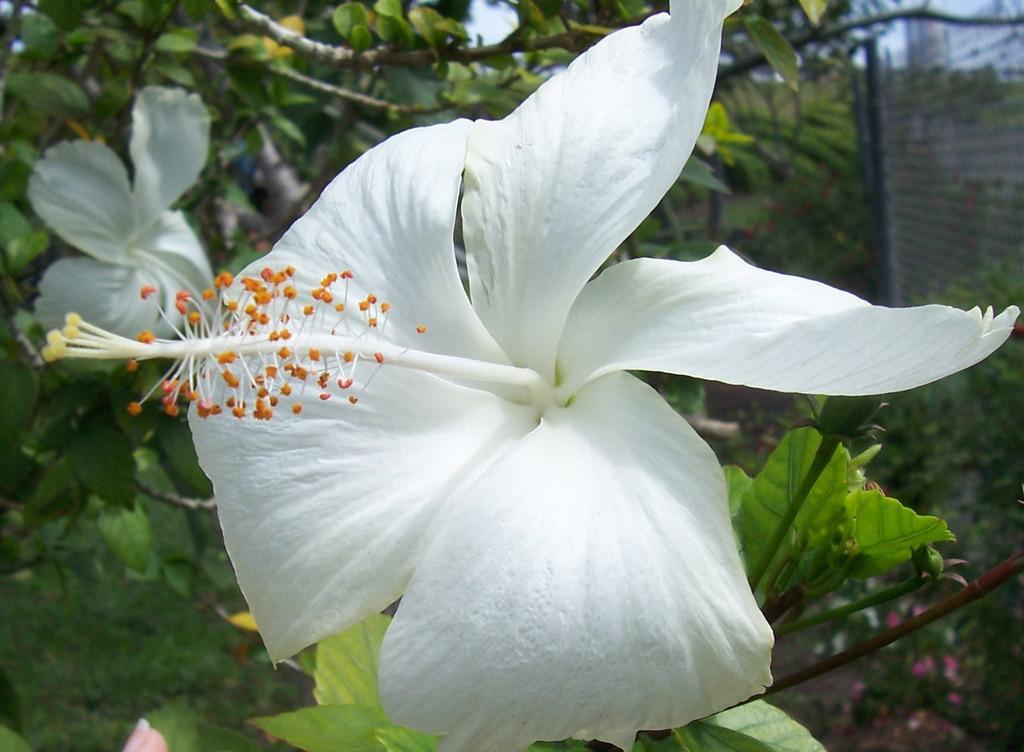Please provide a concise description of this image. In this picture I can see flowers, few plants and trees in the background and I can see a metal fence on the right side. 